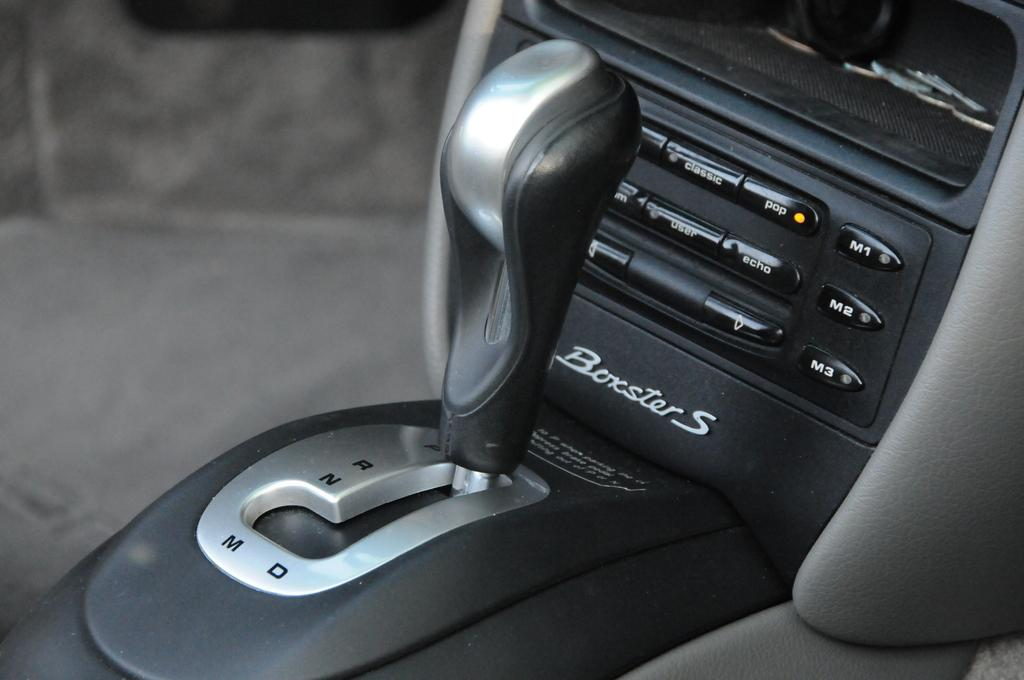What is the main object in the middle of the image? There is a gear rod in the middle of the image. What can be seen on the right side of the image? There appears to be a dashboard of a vehicle on the right side of the image. What type of disease is affecting the heart in the image? There is no heart or disease present in the image; it features a gear rod and a dashboard of a vehicle. 